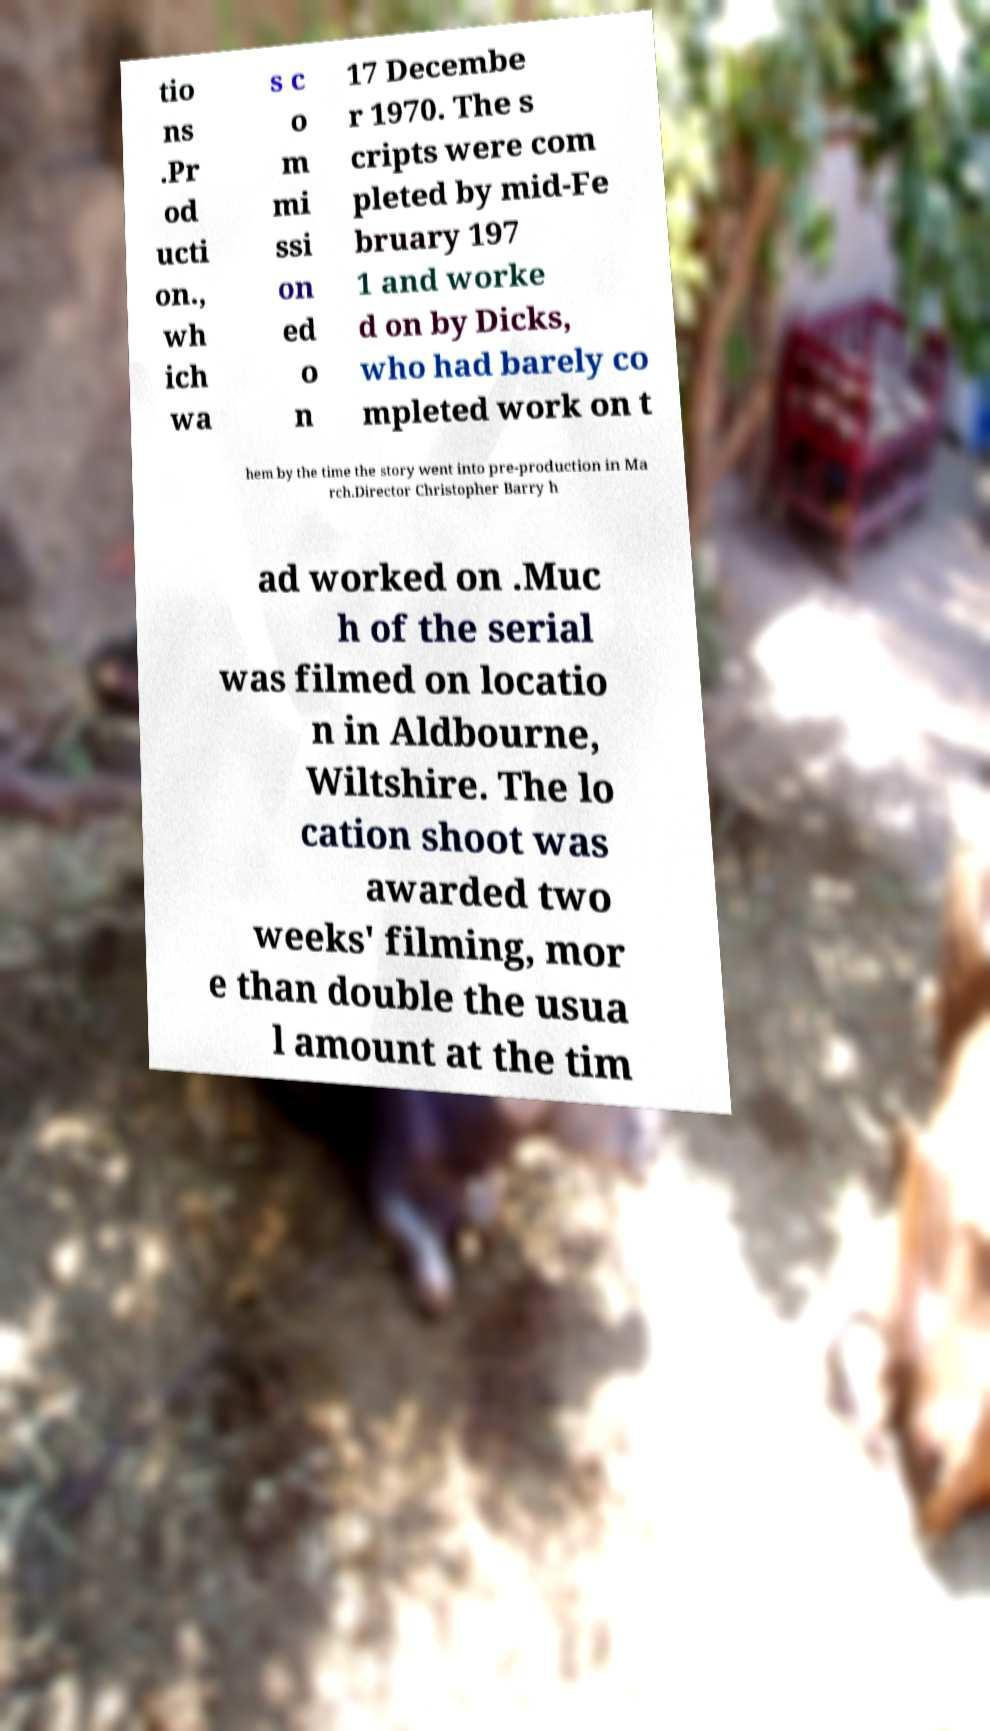There's text embedded in this image that I need extracted. Can you transcribe it verbatim? tio ns .Pr od ucti on., wh ich wa s c o m mi ssi on ed o n 17 Decembe r 1970. The s cripts were com pleted by mid-Fe bruary 197 1 and worke d on by Dicks, who had barely co mpleted work on t hem by the time the story went into pre-production in Ma rch.Director Christopher Barry h ad worked on .Muc h of the serial was filmed on locatio n in Aldbourne, Wiltshire. The lo cation shoot was awarded two weeks' filming, mor e than double the usua l amount at the tim 